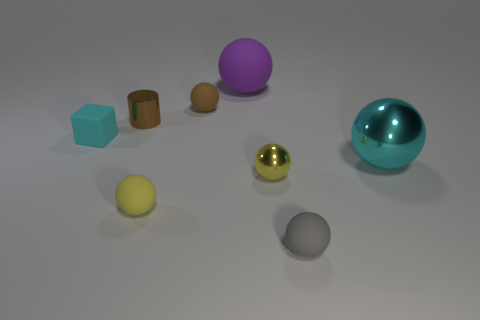Are there an equal number of small things that are on the left side of the small metallic cylinder and large things on the right side of the big purple matte object?
Make the answer very short. Yes. The tiny matte object that is behind the cyan sphere and right of the small cube has what shape?
Make the answer very short. Sphere. What number of things are in front of the purple sphere?
Give a very brief answer. 7. What number of other things are the same shape as the yellow rubber object?
Your answer should be compact. 5. Is the number of small balls less than the number of small brown matte things?
Keep it short and to the point. No. What size is the thing that is behind the yellow rubber object and to the right of the yellow shiny sphere?
Offer a very short reply. Large. There is a metallic ball in front of the cyan object that is on the right side of the matte object that is right of the big purple matte thing; what size is it?
Provide a succinct answer. Small. The cyan rubber block is what size?
Provide a short and direct response. Small. Are there any other things that are the same material as the tiny block?
Provide a short and direct response. Yes. Is there a tiny shiny cylinder that is behind the metallic object that is behind the cyan object that is right of the big rubber object?
Your response must be concise. No. 